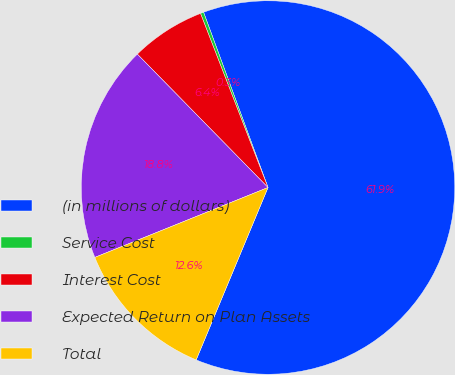Convert chart. <chart><loc_0><loc_0><loc_500><loc_500><pie_chart><fcel>(in millions of dollars)<fcel>Service Cost<fcel>Interest Cost<fcel>Expected Return on Plan Assets<fcel>Total<nl><fcel>61.9%<fcel>0.28%<fcel>6.45%<fcel>18.77%<fcel>12.61%<nl></chart> 